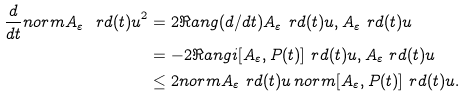<formula> <loc_0><loc_0><loc_500><loc_500>\frac { d } { d t } n o r m { A _ { \varepsilon } \ r d ( t ) u } ^ { 2 } & = 2 \Re a n g { ( d / d t ) A _ { \varepsilon } \ r d ( t ) u , A _ { \varepsilon } \ r d ( t ) u } \\ & = - 2 \Re a n g { i [ A _ { \varepsilon } , P ( t ) ] \ r d ( t ) u , A _ { \varepsilon } \ r d ( t ) u } \\ & \leq 2 n o r m { A _ { \varepsilon } \ r d ( t ) u } \, n o r m { [ A _ { \varepsilon } , P ( t ) ] \ r d ( t ) u } .</formula> 